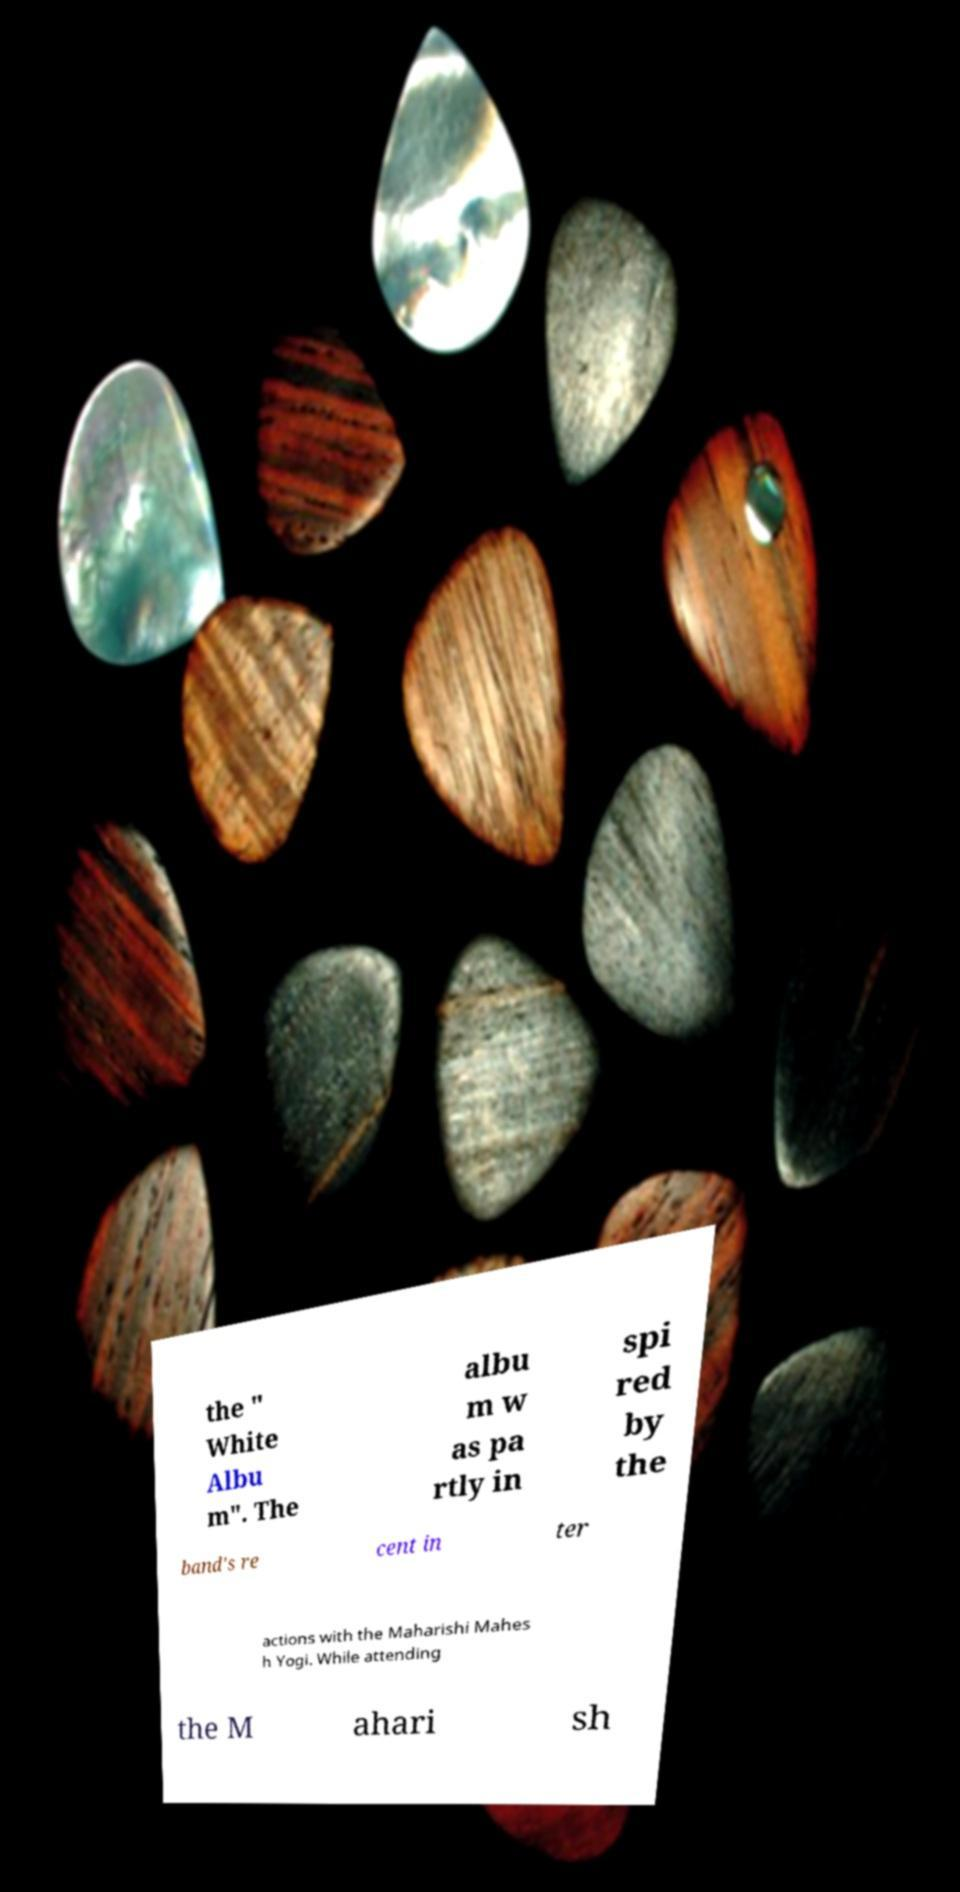Please read and relay the text visible in this image. What does it say? the " White Albu m". The albu m w as pa rtly in spi red by the band's re cent in ter actions with the Maharishi Mahes h Yogi. While attending the M ahari sh 